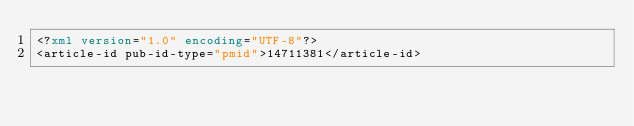<code> <loc_0><loc_0><loc_500><loc_500><_XML_><?xml version="1.0" encoding="UTF-8"?>
<article-id pub-id-type="pmid">14711381</article-id>
</code> 